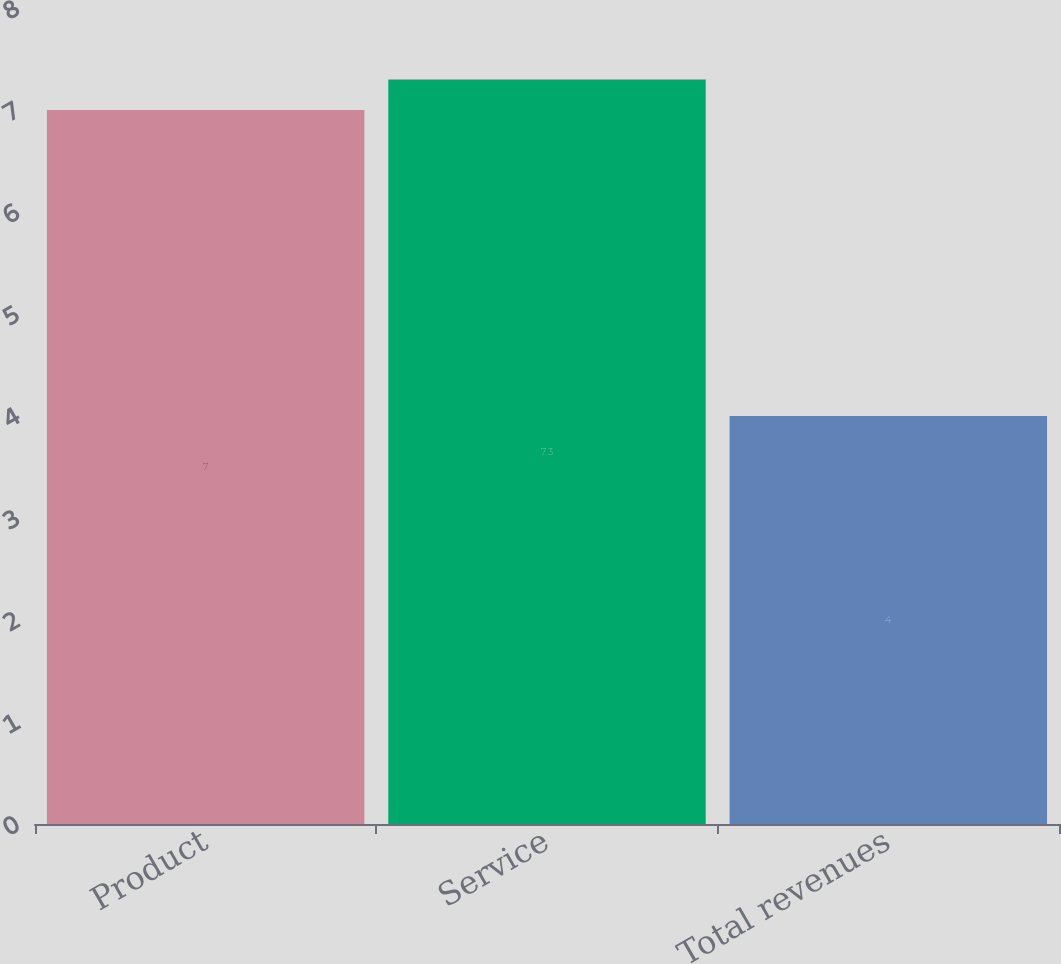<chart> <loc_0><loc_0><loc_500><loc_500><bar_chart><fcel>Product<fcel>Service<fcel>Total revenues<nl><fcel>7<fcel>7.3<fcel>4<nl></chart> 